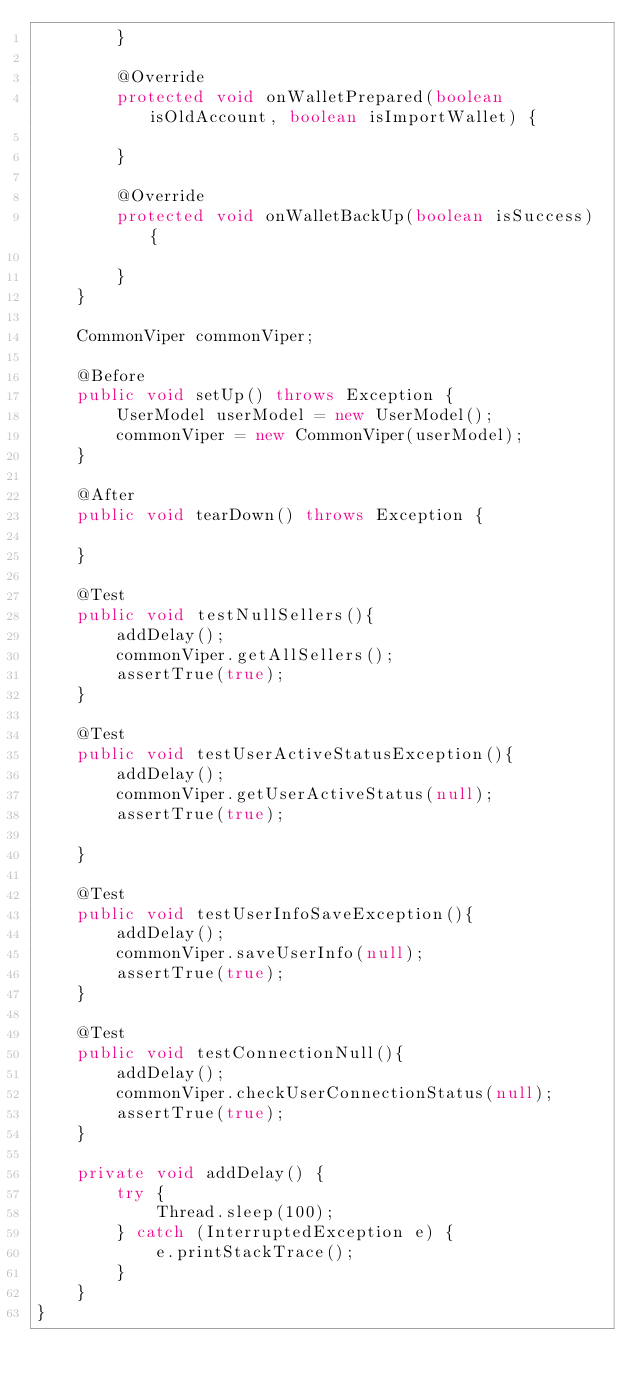<code> <loc_0><loc_0><loc_500><loc_500><_Java_>        }

        @Override
        protected void onWalletPrepared(boolean isOldAccount, boolean isImportWallet) {

        }

        @Override
        protected void onWalletBackUp(boolean isSuccess) {

        }
    }

    CommonViper commonViper;

    @Before
    public void setUp() throws Exception {
        UserModel userModel = new UserModel();
        commonViper = new CommonViper(userModel);
    }

    @After
    public void tearDown() throws Exception {

    }

    @Test
    public void testNullSellers(){
        addDelay();
        commonViper.getAllSellers();
        assertTrue(true);
    }

    @Test
    public void testUserActiveStatusException(){
        addDelay();
        commonViper.getUserActiveStatus(null);
        assertTrue(true);

    }

    @Test
    public void testUserInfoSaveException(){
        addDelay();
        commonViper.saveUserInfo(null);
        assertTrue(true);
    }

    @Test
    public void testConnectionNull(){
        addDelay();
        commonViper.checkUserConnectionStatus(null);
        assertTrue(true);
    }

    private void addDelay() {
        try {
            Thread.sleep(100);
        } catch (InterruptedException e) {
            e.printStackTrace();
        }
    }
}
</code> 